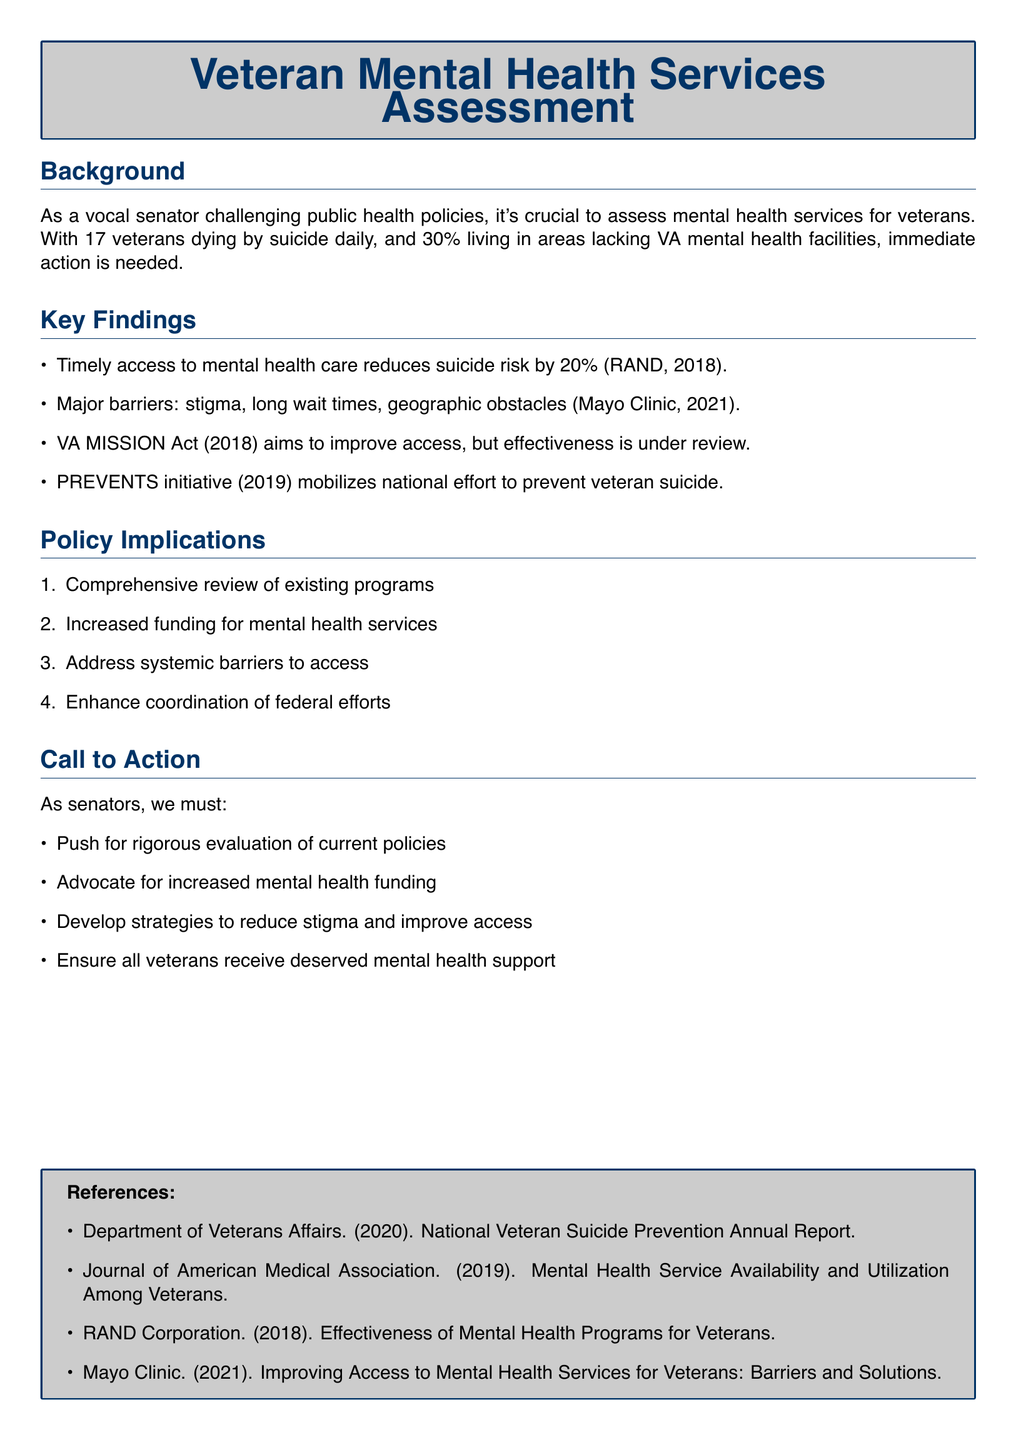What is the daily suicide rate among veterans? The document states that 17 veterans die by suicide daily, which highlights the severity of the issue.
Answer: 17 What percentage of veterans live in areas lacking VA mental health facilities? The document indicates that 30% of veterans live in these areas, emphasizing accessibility challenges.
Answer: 30% What effect does timely access to mental health care have on suicide risk? According to the document, timely access to mental health care reduces suicide risk by 20%.
Answer: 20% What act aims to improve access to veteran mental health services? The VA MISSION Act, as mentioned in the document, focuses on enhancing access to these services.
Answer: VA MISSION Act Which initiative was launched in 2019 to prevent veteran suicide? The document refers to the PREVENTS initiative as the national effort initiated for this purpose.
Answer: PREVENTS What is one major barrier to mental health care access mentioned? Stigma is listed as one of the major barriers to accessing mental health services for veterans in the document.
Answer: Stigma What is one call to action for senators regarding veteran mental health? The document calls for senators to advocate for increased mental health funding as a necessary step.
Answer: Increased mental health funding Which organization published a report on the effectiveness of mental health programs for veterans? The RAND Corporation is cited in the document for assessing the effectiveness of these programs.
Answer: RAND Corporation What type of review is suggested for existing programs? A comprehensive review of existing programs is recommended in the policy implications section of the document.
Answer: Comprehensive review 